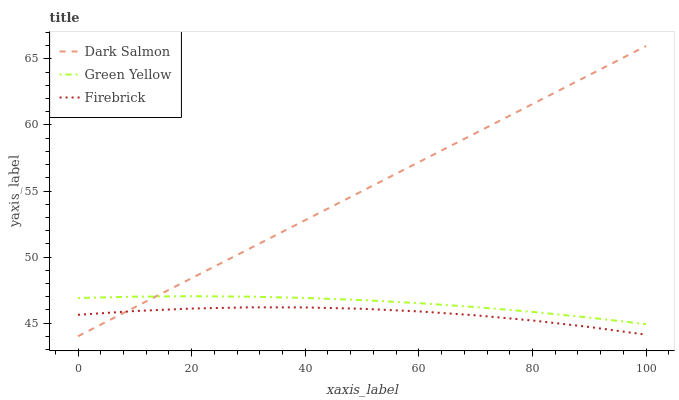Does Green Yellow have the minimum area under the curve?
Answer yes or no. No. Does Green Yellow have the maximum area under the curve?
Answer yes or no. No. Is Green Yellow the smoothest?
Answer yes or no. No. Is Green Yellow the roughest?
Answer yes or no. No. Does Green Yellow have the lowest value?
Answer yes or no. No. Does Green Yellow have the highest value?
Answer yes or no. No. Is Firebrick less than Green Yellow?
Answer yes or no. Yes. Is Green Yellow greater than Firebrick?
Answer yes or no. Yes. Does Firebrick intersect Green Yellow?
Answer yes or no. No. 